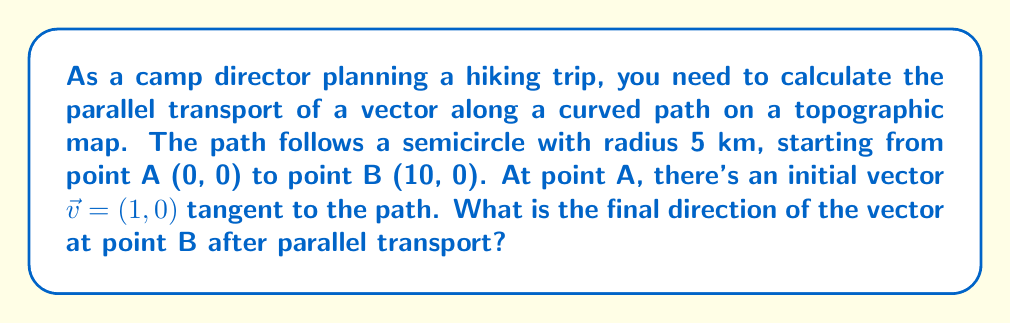What is the answer to this math problem? To solve this problem, we'll follow these steps:

1) First, we need to understand that parallel transport preserves the angle between the vector and the curve. In this case, the vector starts tangent to the curve.

2) The path is a semicircle, which means it covers an angle of $\pi$ radians or 180°.

3) For a circle (or semicircle), the parallel transport of a vector results in a rotation of the vector. The angle of rotation is equal to the angle subtended by the arc at the center.

4) In this case, the vector will rotate by $\pi$ radians (180°) in the counterclockwise direction.

5) We can represent this rotation using a rotation matrix:

   $$R = \begin{pmatrix} 
   \cos \pi & -\sin \pi \\
   \sin \pi & \cos \pi
   \end{pmatrix} = \begin{pmatrix} 
   -1 & 0 \\
   0 & -1
   \end{pmatrix}$$

6) Applying this rotation to the initial vector:

   $$\vec{v}_{\text{final}} = R \vec{v}_{\text{initial}} = \begin{pmatrix} 
   -1 & 0 \\
   0 & -1
   \end{pmatrix} \begin{pmatrix} 
   1 \\
   0
   \end{pmatrix} = \begin{pmatrix} 
   -1 \\
   0
   \end{pmatrix}$$

7) Therefore, the final vector after parallel transport is $(-1, 0)$.
Answer: $(-1, 0)$ 